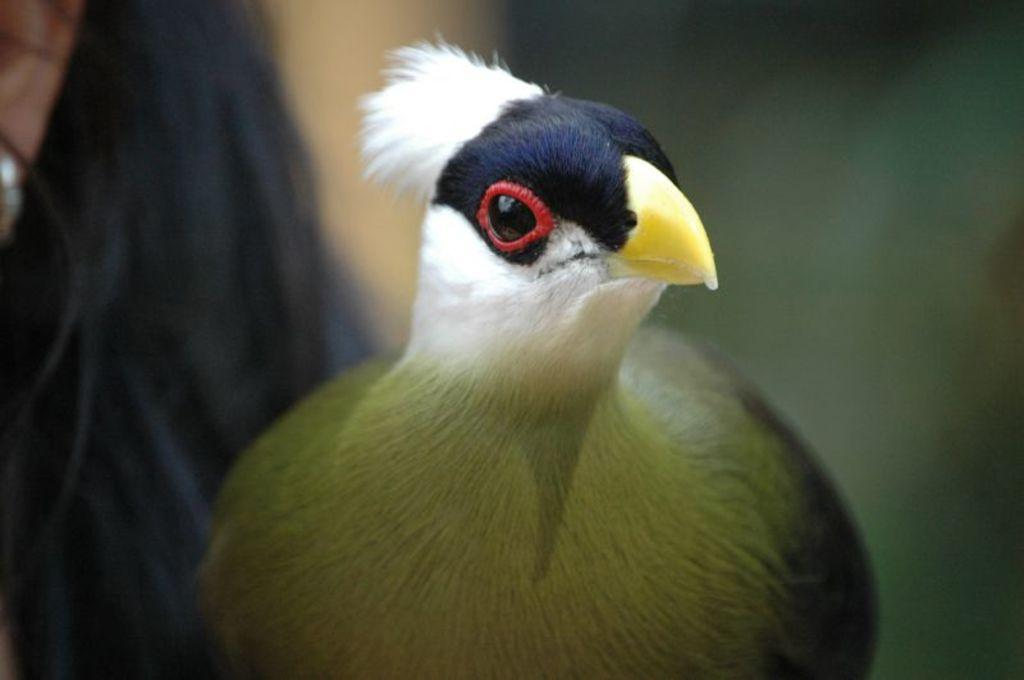What type of animal is present in the image? There is a bird in the image. Can you describe the background of the image? The background of the image is blurred. How does the bird help with the quince harvest in the image? There is no quince harvest present in the image, and the bird is not shown helping with any task. 